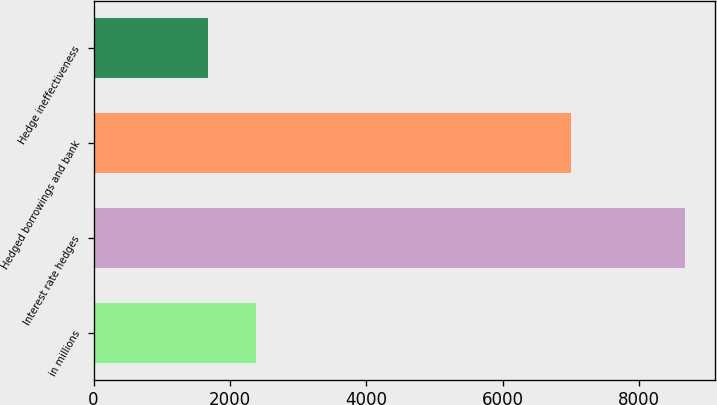Convert chart to OTSL. <chart><loc_0><loc_0><loc_500><loc_500><bar_chart><fcel>in millions<fcel>Interest rate hedges<fcel>Hedged borrowings and bank<fcel>Hedge ineffectiveness<nl><fcel>2383.9<fcel>8683<fcel>6999<fcel>1684<nl></chart> 